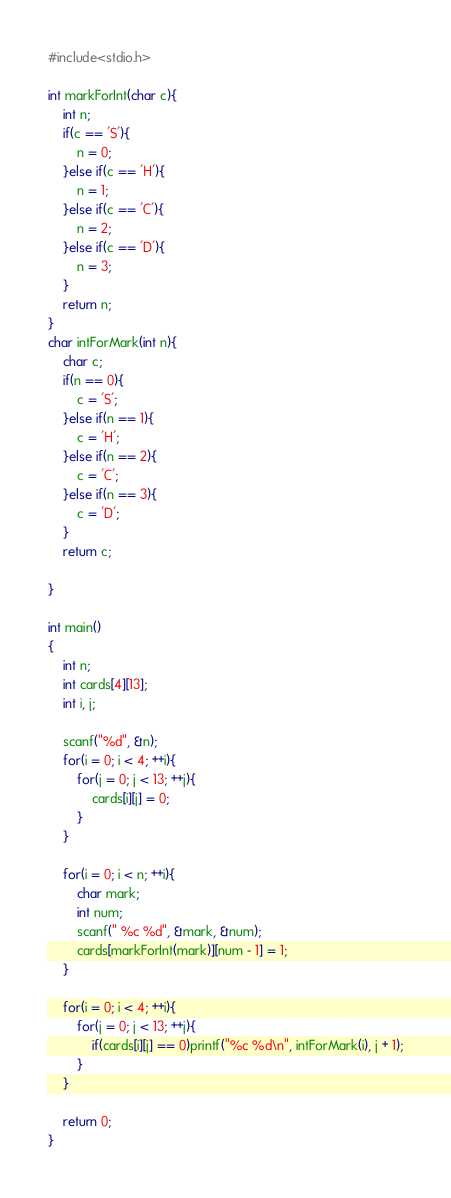<code> <loc_0><loc_0><loc_500><loc_500><_C_>#include<stdio.h>

int markForInt(char c){
	int n;
	if(c == 'S'){
		n = 0;
	}else if(c == 'H'){
		n = 1;
	}else if(c == 'C'){
		n = 2;
	}else if(c == 'D'){
		n = 3;
	}
	return n;
}
char intForMark(int n){
	char c;
	if(n == 0){
		c = 'S';
	}else if(n == 1){
		c = 'H';
	}else if(n == 2){
		c = 'C';
	}else if(n == 3){
		c = 'D';
	}
	return c;

}

int main()
{
	int n;
	int cards[4][13];
	int i, j;
		
	scanf("%d", &n);
	for(i = 0; i < 4; ++i){
		for(j = 0; j < 13; ++j){
			cards[i][j] = 0;
		}
	}
	
	for(i = 0; i < n; ++i){
		char mark;
		int num;
		scanf(" %c %d", &mark, &num);
		cards[markForInt(mark)][num - 1] = 1;
	}
	
	for(i = 0; i < 4; ++i){
		for(j = 0; j < 13; ++j){
			if(cards[i][j] == 0)printf("%c %d\n", intForMark(i), j + 1);
		}
	}

	return 0;
}</code> 